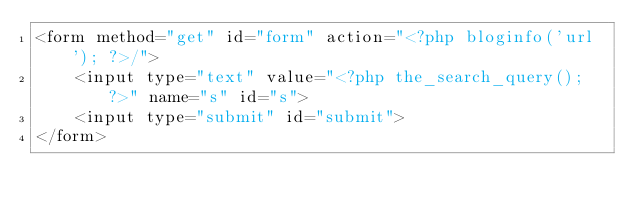Convert code to text. <code><loc_0><loc_0><loc_500><loc_500><_PHP_><form method="get" id="form" action="<?php bloginfo('url'); ?>/">
    <input type="text" value="<?php the_search_query(); ?>" name="s" id="s">
    <input type="submit" id="submit">
</form></code> 